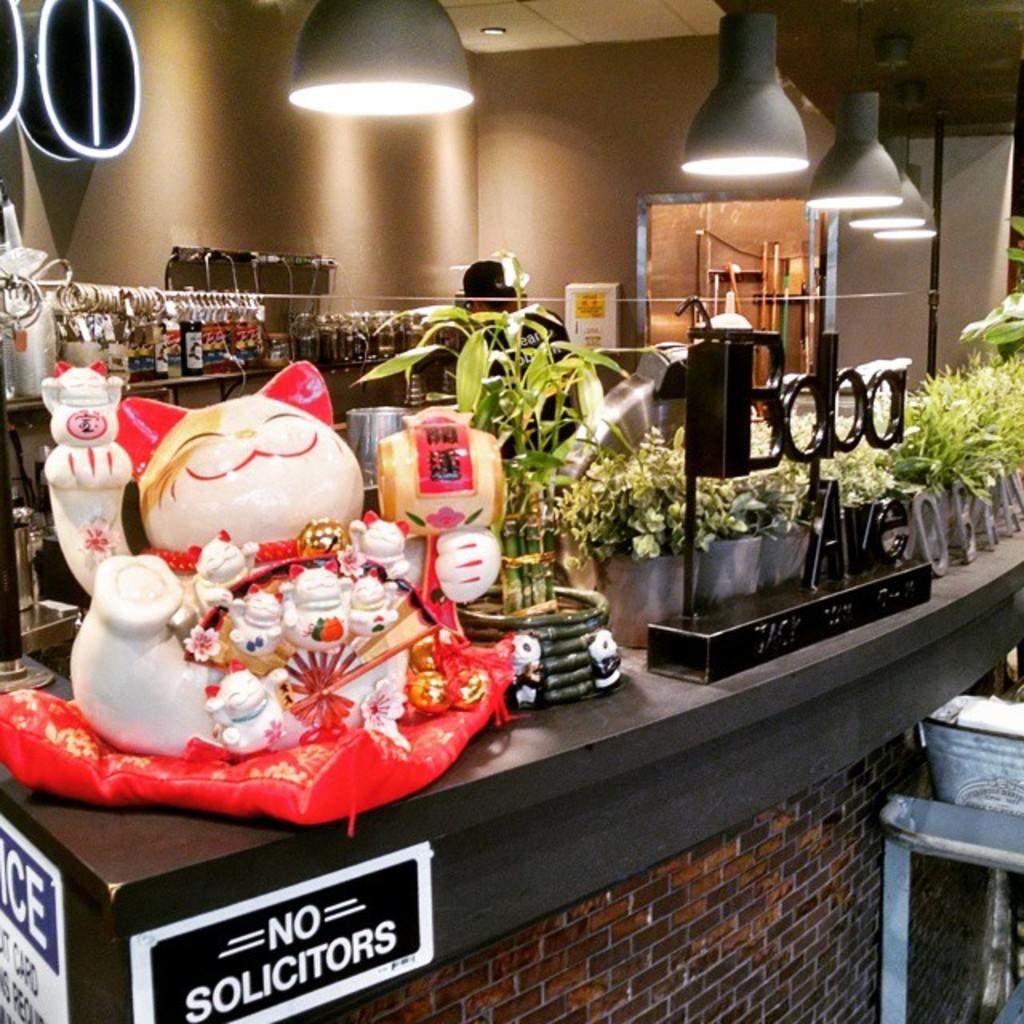<image>
Render a clear and concise summary of the photo. A counter with a cat statue on it has a sign that says No Solicitors. 